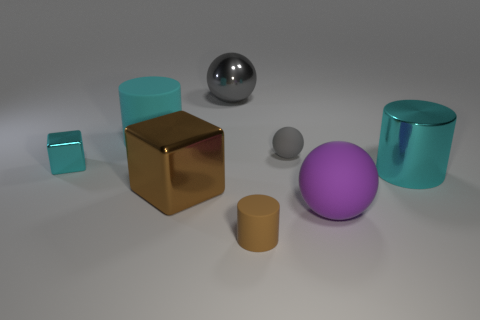Subtract all large cyan cylinders. How many cylinders are left? 1 Add 1 small cyan rubber cylinders. How many objects exist? 9 Subtract 2 cubes. How many cubes are left? 0 Subtract all purple balls. How many balls are left? 2 Subtract all balls. How many objects are left? 5 Subtract all gray cubes. How many brown cylinders are left? 1 Subtract 0 blue spheres. How many objects are left? 8 Subtract all cyan balls. Subtract all brown cylinders. How many balls are left? 3 Subtract all large cyan cylinders. Subtract all cyan rubber objects. How many objects are left? 5 Add 7 tiny gray matte spheres. How many tiny gray matte spheres are left? 8 